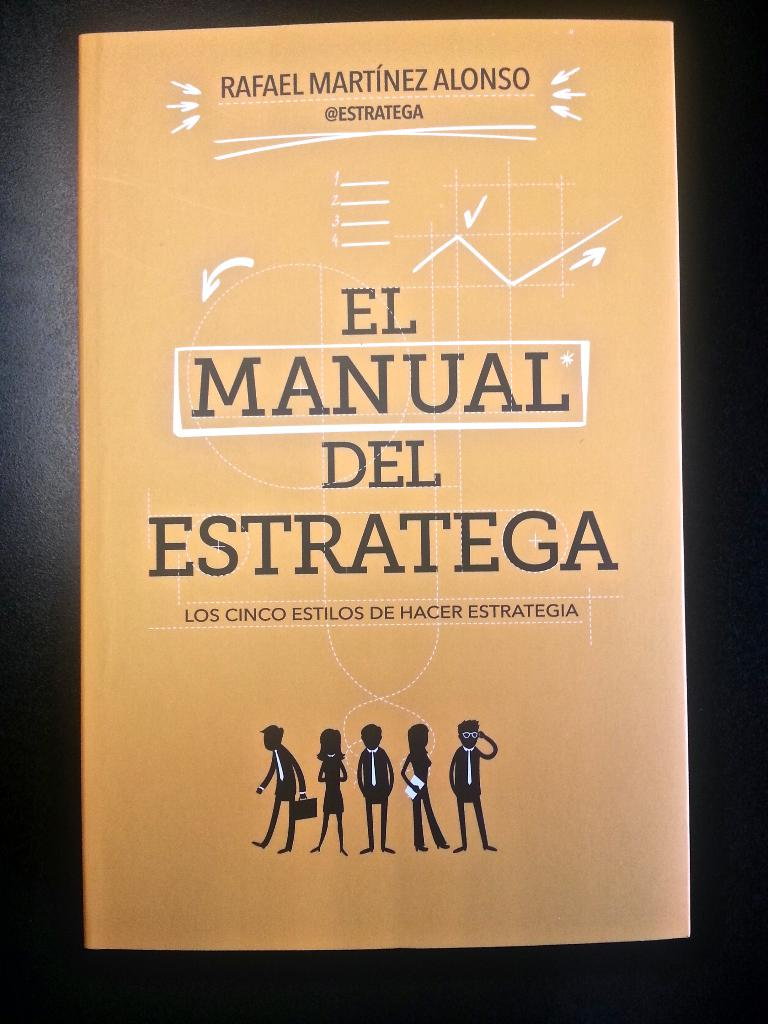What do you see happening in this image? The image features the cover of a book titled "El Manual Estratega" authored by Rafael Martínez Alonso. The cover is predominantly orange with the title and author's name displayed in white text. The subtitle, "Los Cinco Estilos De Hacer Estrategia", suggests that the book delves into five different styles of strategy. The cover also includes illustrations of five individuals in various poses, possibly representing the different strategic styles discussed within the book. The author's social media handle, "@Estratega", is also visible, indicating their online presence. Overall, the image conveys that this is a book about strategic thinking and its various approaches. 